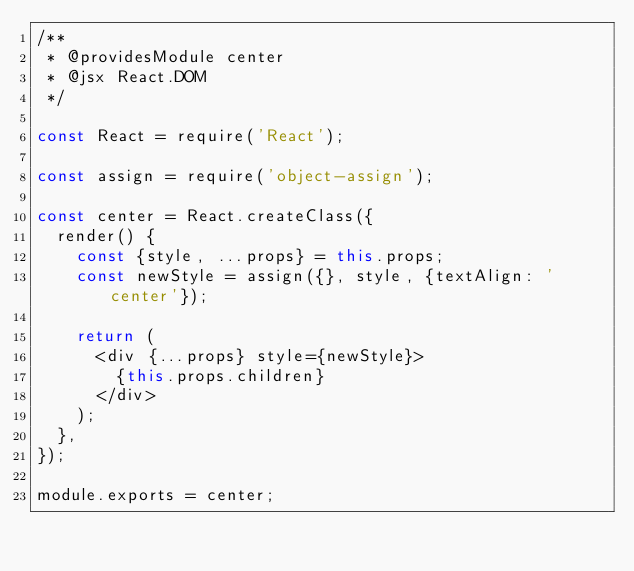<code> <loc_0><loc_0><loc_500><loc_500><_JavaScript_>/**
 * @providesModule center
 * @jsx React.DOM
 */

const React = require('React');

const assign = require('object-assign');

const center = React.createClass({
  render() {
    const {style, ...props} = this.props;
    const newStyle = assign({}, style, {textAlign: 'center'});

    return (
      <div {...props} style={newStyle}>
        {this.props.children}
      </div>
    );
  },
});

module.exports = center;
</code> 